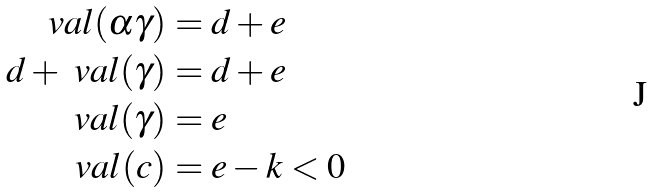<formula> <loc_0><loc_0><loc_500><loc_500>\ v a l ( \alpha \gamma ) & = d + e \\ d + \ v a l ( \gamma ) & = d + e \\ \ v a l ( \gamma ) & = e \\ \ v a l ( c ) & = e - k < 0</formula> 